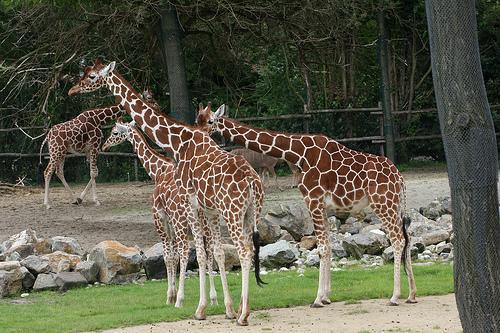How many giraffes are pictured here?
Give a very brief answer. 4. How many people are in this picture?
Give a very brief answer. 0. 